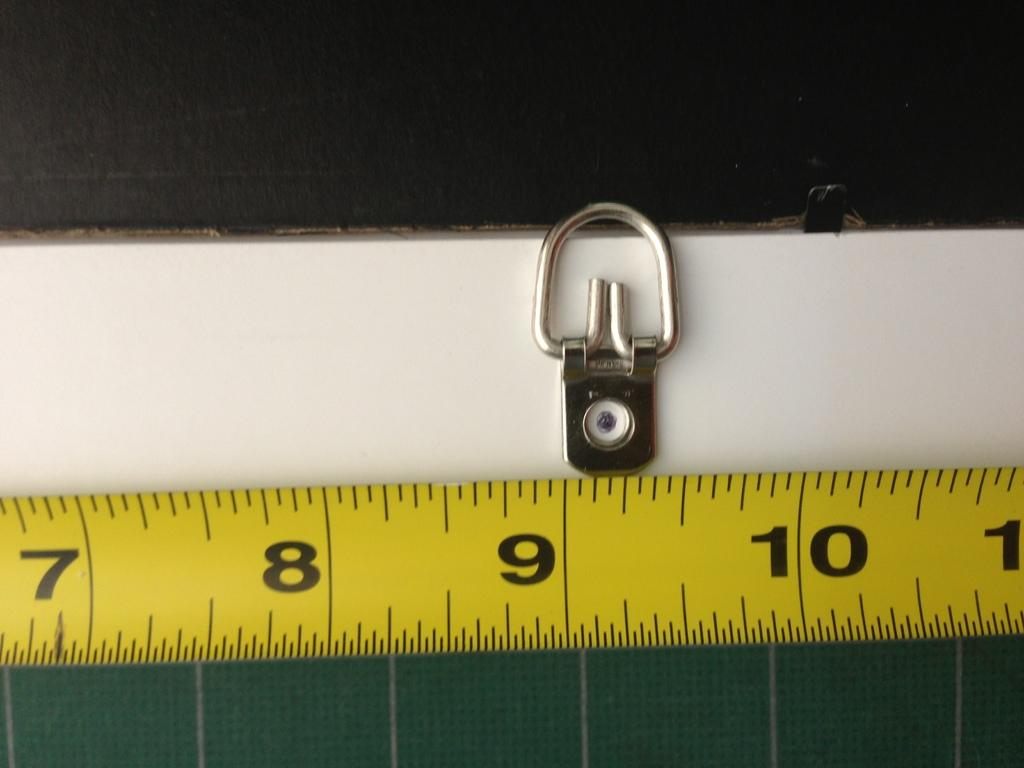<image>
Provide a brief description of the given image. A piece of a yellow measuring tape showing the length from 7 to almost 11 inches. 